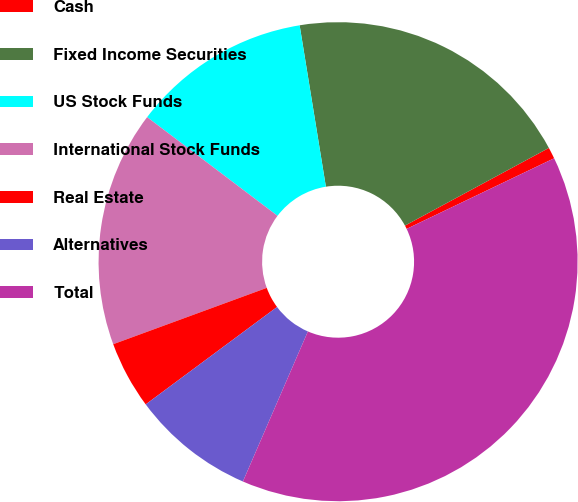<chart> <loc_0><loc_0><loc_500><loc_500><pie_chart><fcel>Cash<fcel>Fixed Income Securities<fcel>US Stock Funds<fcel>International Stock Funds<fcel>Real Estate<fcel>Alternatives<fcel>Total<nl><fcel>0.77%<fcel>19.69%<fcel>12.12%<fcel>15.91%<fcel>4.56%<fcel>8.34%<fcel>38.61%<nl></chart> 